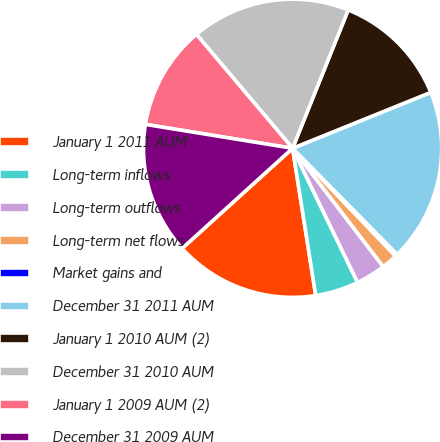<chart> <loc_0><loc_0><loc_500><loc_500><pie_chart><fcel>January 1 2011 AUM<fcel>Long-term inflows<fcel>Long-term outflows<fcel>Long-term net flows<fcel>Market gains and<fcel>December 31 2011 AUM<fcel>January 1 2010 AUM (2)<fcel>December 31 2010 AUM<fcel>January 1 2009 AUM (2)<fcel>December 31 2009 AUM<nl><fcel>15.76%<fcel>4.7%<fcel>3.22%<fcel>1.73%<fcel>0.25%<fcel>18.73%<fcel>12.8%<fcel>17.24%<fcel>11.28%<fcel>14.28%<nl></chart> 